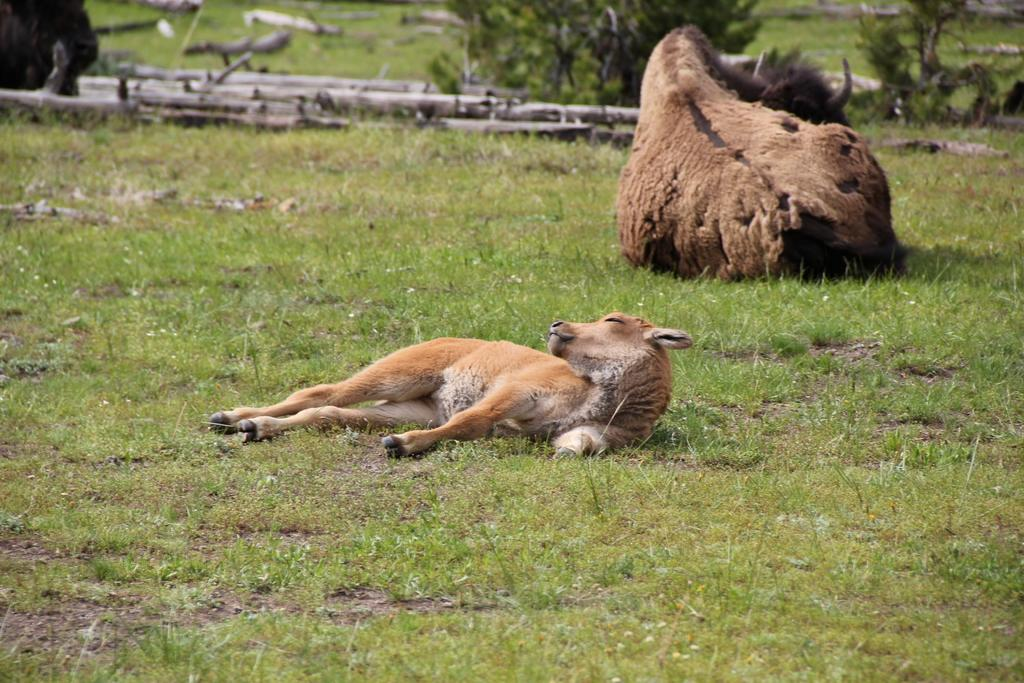What type of animals can be seen in the image? There are animals on the grass in the image. What can be seen in the background of the image? There are wooden sticks and plants in the background of the image. What type of mask is the animal wearing in the image? There is no mask present on the animals in the image. What type of hat is the animal wearing in the image? There is no hat present on the animals in the image. 